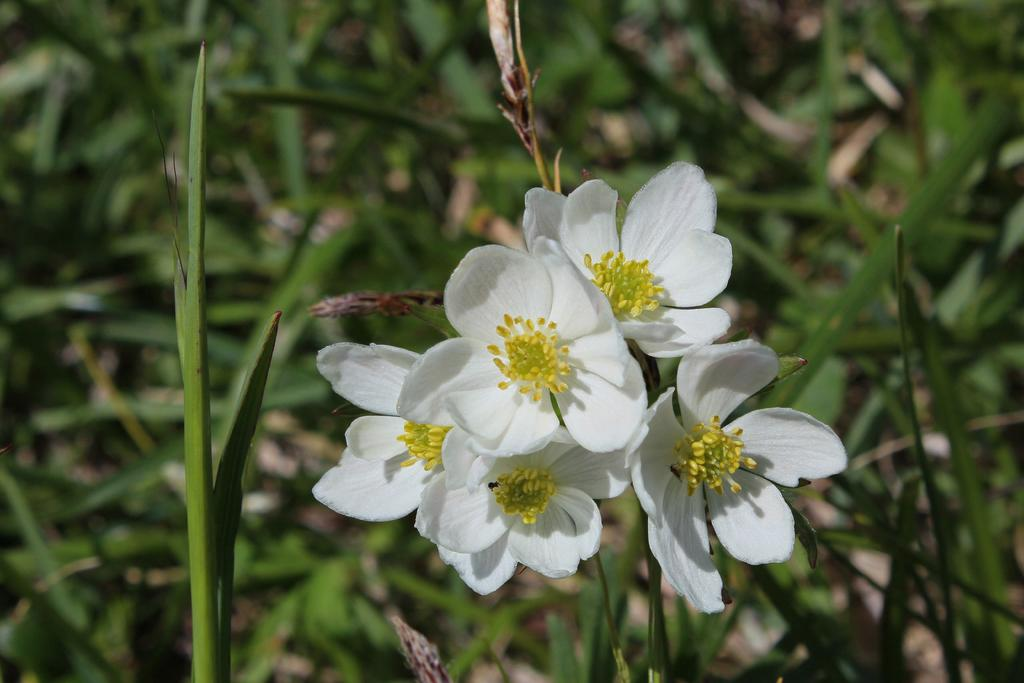What type of living organisms can be seen in the image? Plants can be seen in the image. Can you describe the flowers on the plants? There are white color flowers on the plants in the image. Where can the notebook be found in the image? There is no notebook present in the image. What is the store selling in the image? There is no store present in the image. 